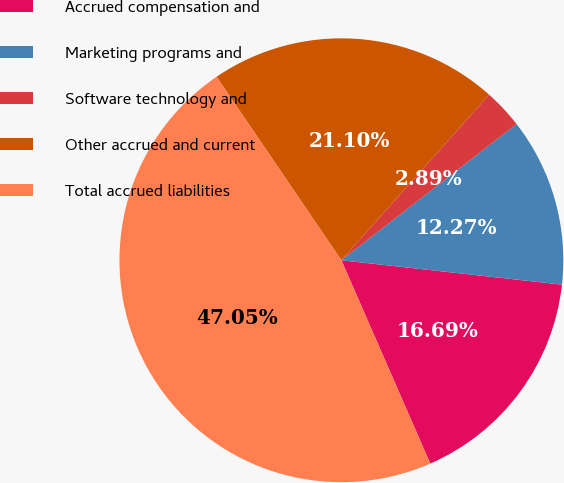Convert chart. <chart><loc_0><loc_0><loc_500><loc_500><pie_chart><fcel>Accrued compensation and<fcel>Marketing programs and<fcel>Software technology and<fcel>Other accrued and current<fcel>Total accrued liabilities<nl><fcel>16.69%<fcel>12.27%<fcel>2.89%<fcel>21.1%<fcel>47.05%<nl></chart> 